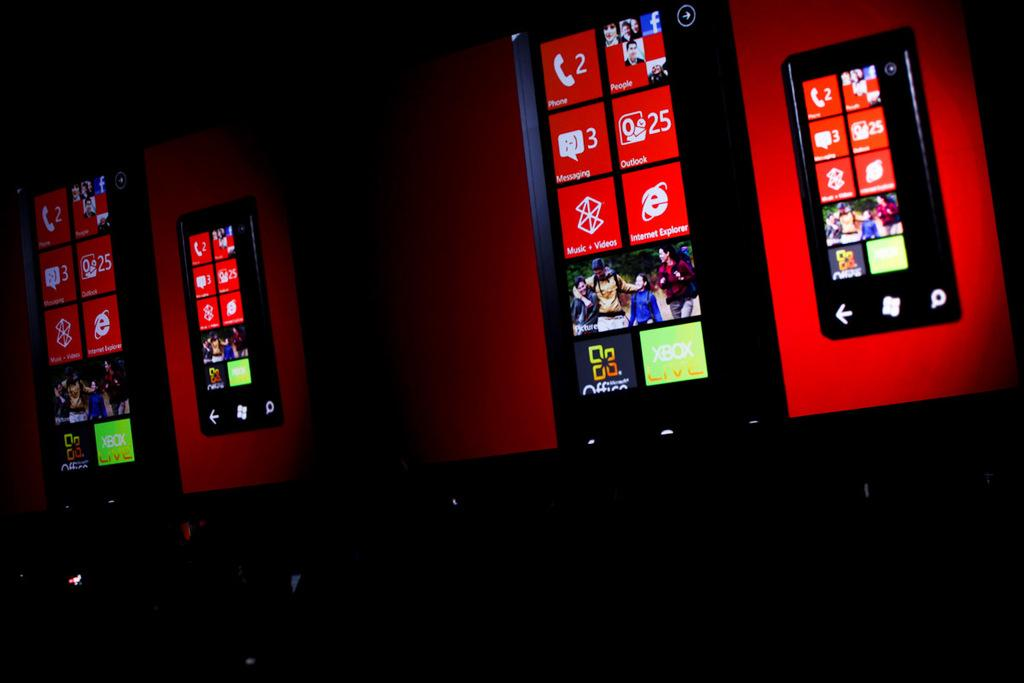<image>
Offer a succinct explanation of the picture presented. The phone display shows two missed calls and three missed text messages. 